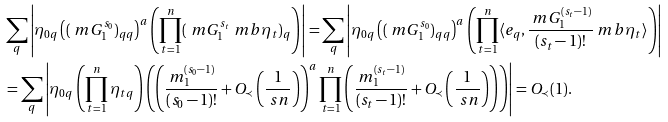<formula> <loc_0><loc_0><loc_500><loc_500>& \sum _ { q } \left | \eta _ { 0 q } \left ( ( \ m G _ { 1 } ^ { s _ { 0 } } ) _ { q q } \right ) ^ { a } \left ( \prod _ { t = 1 } ^ { n } ( \ m G _ { 1 } ^ { s _ { t } } \ m b { \eta } _ { t } ) _ { q } \right ) \right | = \sum _ { q } \left | \eta _ { 0 q } \left ( ( \ m G _ { 1 } ^ { s _ { 0 } } ) _ { q q } \right ) ^ { a } \left ( \prod _ { t = 1 } ^ { n } \langle e _ { q } , \frac { \ m G _ { 1 } ^ { ( s _ { t } - 1 ) } } { ( s _ { t } - 1 ) ! } \ m b { \eta } _ { t } \rangle \right ) \right | \\ & = \sum _ { q } \left | \eta _ { 0 q } \left ( \prod _ { t = 1 } ^ { n } \eta _ { t q } \right ) \left ( \left ( \frac { m _ { 1 } ^ { ( s _ { 0 } - 1 ) } } { ( s _ { 0 } - 1 ) ! } + O _ { \prec } \left ( \frac { 1 } { \ s n } \right ) \right ) ^ { a } \prod _ { t = 1 } ^ { n } \left ( \frac { m _ { 1 } ^ { ( s _ { t } - 1 ) } } { ( s _ { t } - 1 ) ! } + O _ { \prec } \left ( \frac { 1 } { \ s n } \right ) \right ) \right ) \right | = O _ { \prec } ( 1 ) .</formula> 